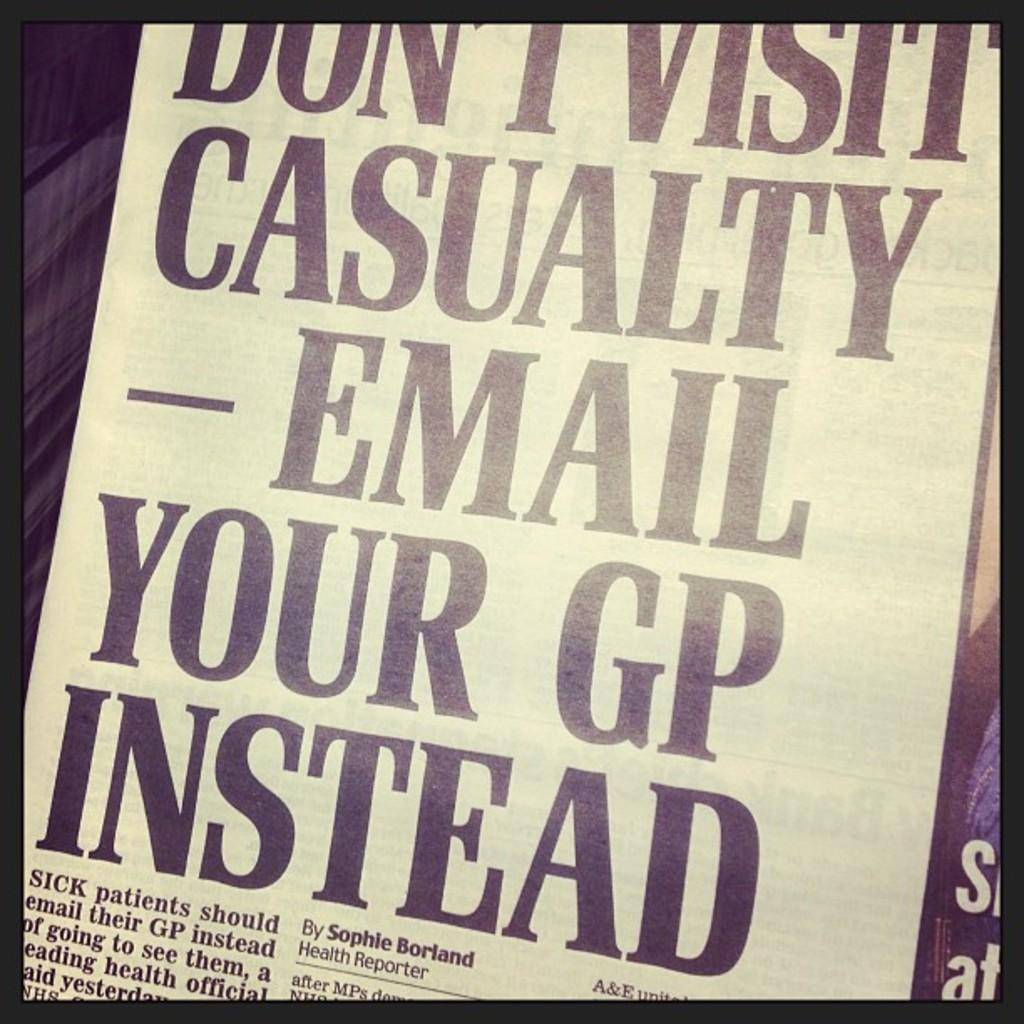<image>
Summarize the visual content of the image. A newspaper article advises people to email their GP instead of visiting casualty. 